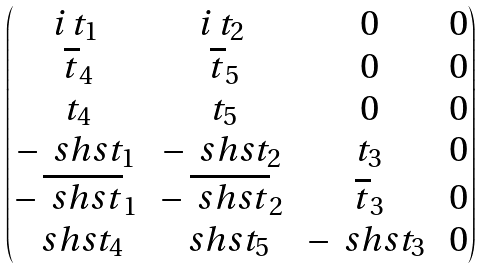Convert formula to latex. <formula><loc_0><loc_0><loc_500><loc_500>\begin{pmatrix} i \, t _ { 1 } \, & i \, t _ { 2 } \, & 0 & 0 \\ \, \overline { t } _ { 4 } \, & \, \overline { t } _ { 5 } \, & 0 & 0 \\ \, t _ { 4 } \, & \, t _ { 5 } \, & 0 & 0 \\ - \, \ s h s { t } _ { 1 } \, & - \, \ s h s { t } _ { 2 } \, & \, t _ { 3 } \, & 0 \\ - \, \overline { \ s h s { t } } _ { 1 } \, & - \, \overline { \ s h s { t } } _ { 2 } \, & \, \overline { t } _ { 3 } \, & 0 \\ \, \ s h s { t } _ { 4 } \, & \, \ s h s { t } _ { 5 } \, & - \, \ s h s { t } _ { 3 } \, & 0 \end{pmatrix}</formula> 